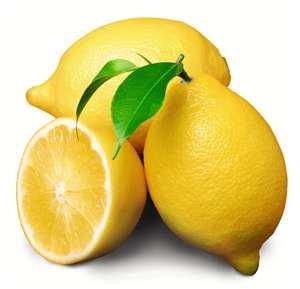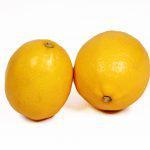The first image is the image on the left, the second image is the image on the right. For the images shown, is this caption "There is one half of a lemon in one of the images." true? Answer yes or no. Yes. 